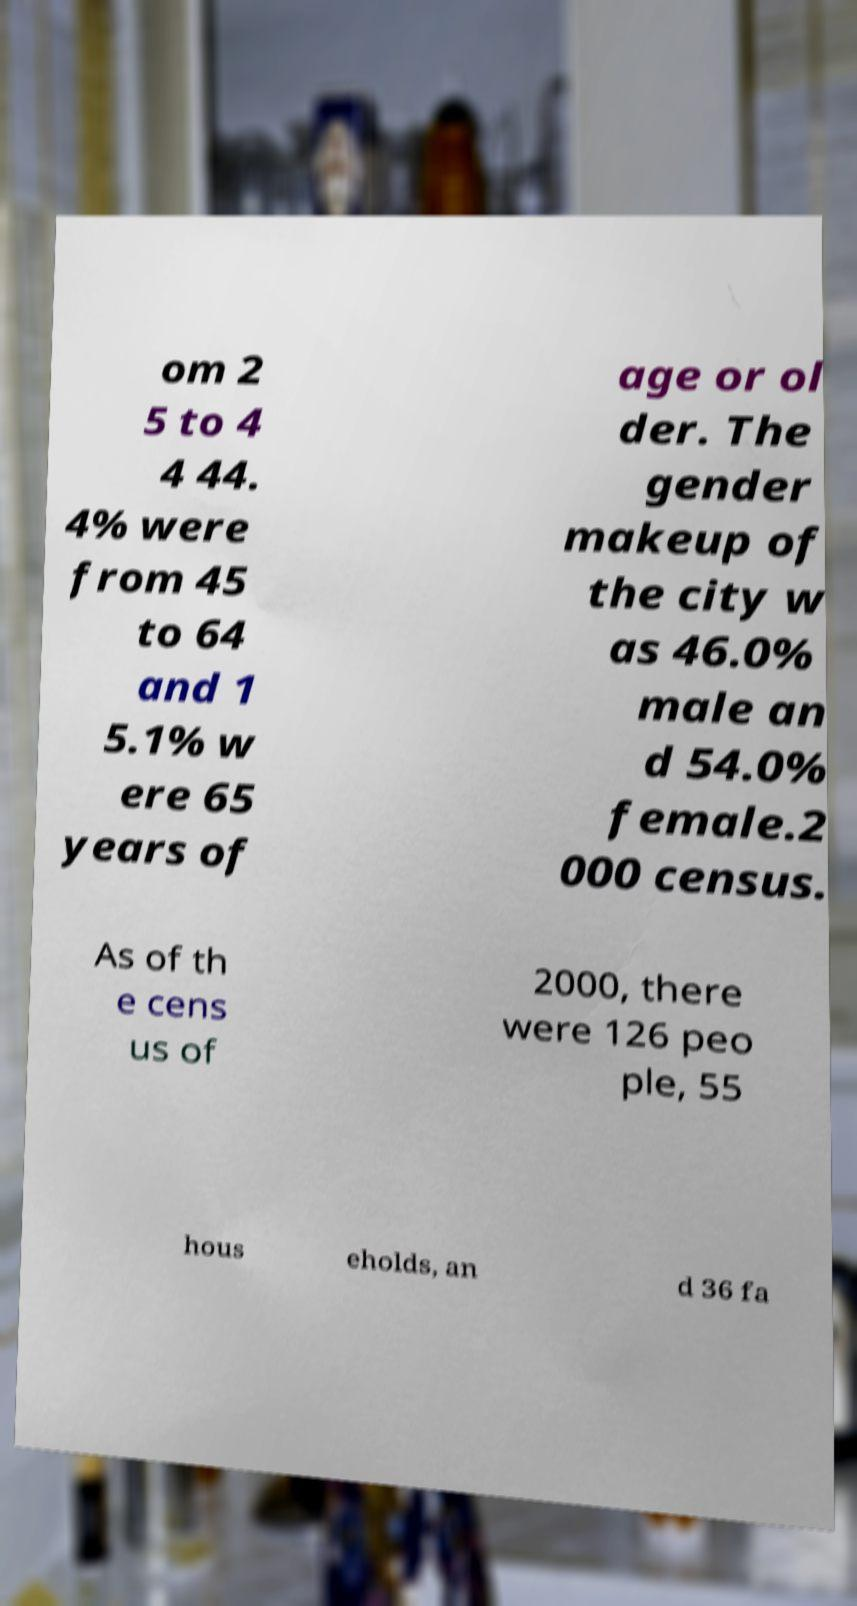There's text embedded in this image that I need extracted. Can you transcribe it verbatim? om 2 5 to 4 4 44. 4% were from 45 to 64 and 1 5.1% w ere 65 years of age or ol der. The gender makeup of the city w as 46.0% male an d 54.0% female.2 000 census. As of th e cens us of 2000, there were 126 peo ple, 55 hous eholds, an d 36 fa 